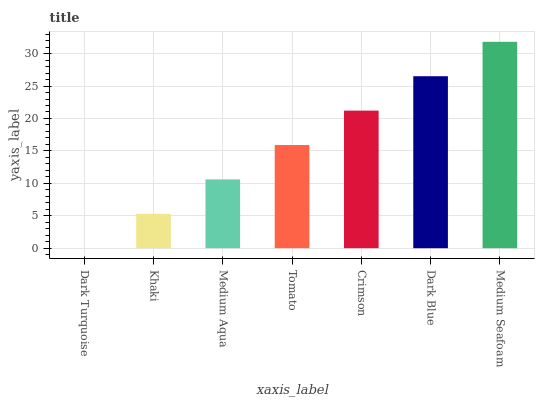Is Dark Turquoise the minimum?
Answer yes or no. Yes. Is Medium Seafoam the maximum?
Answer yes or no. Yes. Is Khaki the minimum?
Answer yes or no. No. Is Khaki the maximum?
Answer yes or no. No. Is Khaki greater than Dark Turquoise?
Answer yes or no. Yes. Is Dark Turquoise less than Khaki?
Answer yes or no. Yes. Is Dark Turquoise greater than Khaki?
Answer yes or no. No. Is Khaki less than Dark Turquoise?
Answer yes or no. No. Is Tomato the high median?
Answer yes or no. Yes. Is Tomato the low median?
Answer yes or no. Yes. Is Medium Seafoam the high median?
Answer yes or no. No. Is Dark Blue the low median?
Answer yes or no. No. 